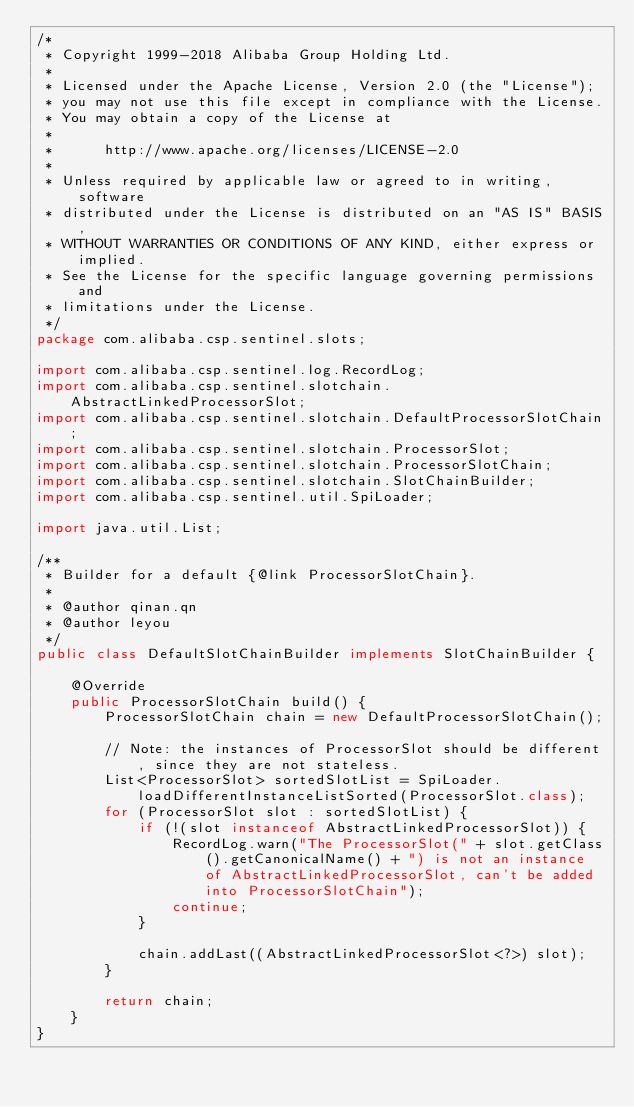<code> <loc_0><loc_0><loc_500><loc_500><_Java_>/*
 * Copyright 1999-2018 Alibaba Group Holding Ltd.
 *
 * Licensed under the Apache License, Version 2.0 (the "License");
 * you may not use this file except in compliance with the License.
 * You may obtain a copy of the License at
 *
 *      http://www.apache.org/licenses/LICENSE-2.0
 *
 * Unless required by applicable law or agreed to in writing, software
 * distributed under the License is distributed on an "AS IS" BASIS,
 * WITHOUT WARRANTIES OR CONDITIONS OF ANY KIND, either express or implied.
 * See the License for the specific language governing permissions and
 * limitations under the License.
 */
package com.alibaba.csp.sentinel.slots;

import com.alibaba.csp.sentinel.log.RecordLog;
import com.alibaba.csp.sentinel.slotchain.AbstractLinkedProcessorSlot;
import com.alibaba.csp.sentinel.slotchain.DefaultProcessorSlotChain;
import com.alibaba.csp.sentinel.slotchain.ProcessorSlot;
import com.alibaba.csp.sentinel.slotchain.ProcessorSlotChain;
import com.alibaba.csp.sentinel.slotchain.SlotChainBuilder;
import com.alibaba.csp.sentinel.util.SpiLoader;

import java.util.List;

/**
 * Builder for a default {@link ProcessorSlotChain}.
 *
 * @author qinan.qn
 * @author leyou
 */
public class DefaultSlotChainBuilder implements SlotChainBuilder {

    @Override
    public ProcessorSlotChain build() {
        ProcessorSlotChain chain = new DefaultProcessorSlotChain();

        // Note: the instances of ProcessorSlot should be different, since they are not stateless.
        List<ProcessorSlot> sortedSlotList = SpiLoader.loadDifferentInstanceListSorted(ProcessorSlot.class);
        for (ProcessorSlot slot : sortedSlotList) {
            if (!(slot instanceof AbstractLinkedProcessorSlot)) {
                RecordLog.warn("The ProcessorSlot(" + slot.getClass().getCanonicalName() + ") is not an instance of AbstractLinkedProcessorSlot, can't be added into ProcessorSlotChain");
                continue;
            }

            chain.addLast((AbstractLinkedProcessorSlot<?>) slot);
        }

        return chain;
    }
}
</code> 